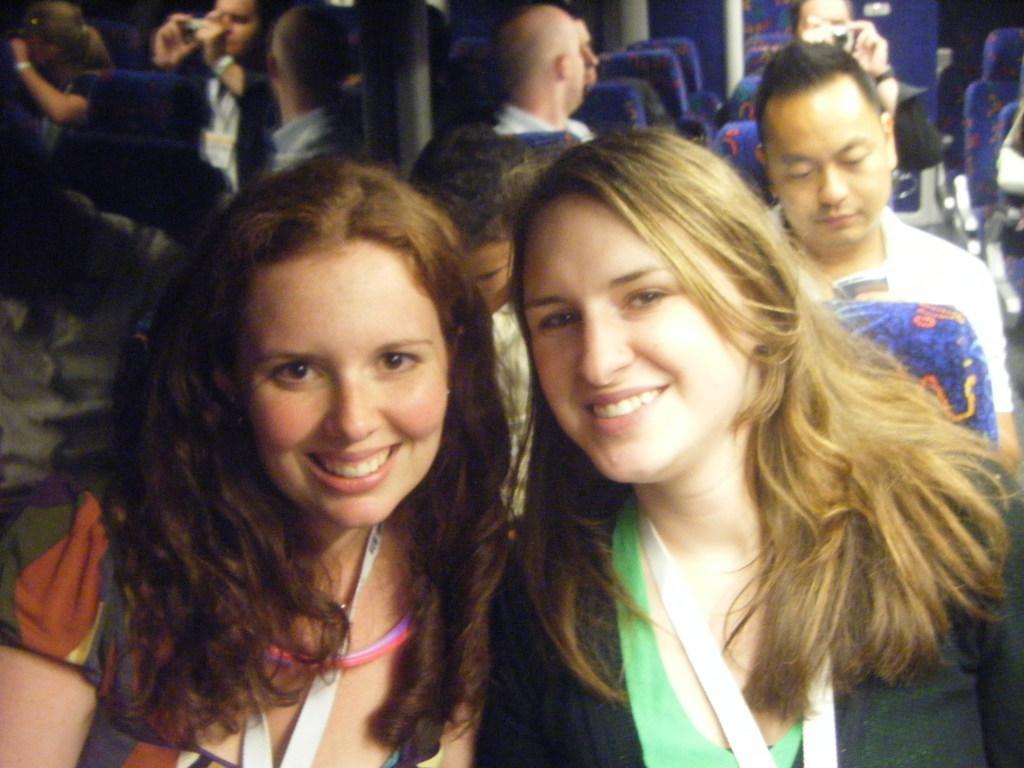Please provide a concise description of this image. The picture is clicked inside a vehicle. There are many chairs. Few people are sitting on chairs. In the foreground two ladies are sitting. They are smiling. This is looking like a mirror. 